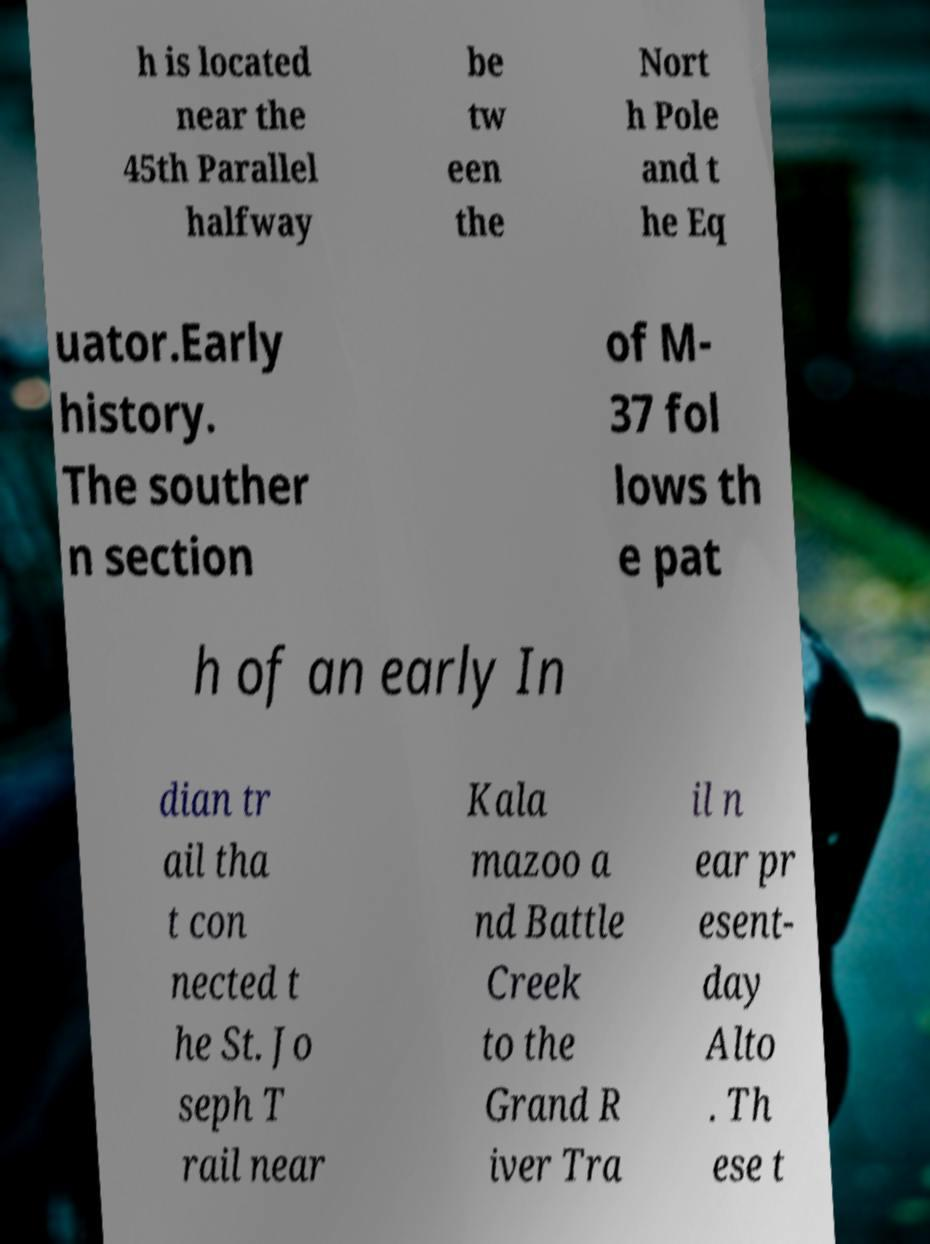Can you read and provide the text displayed in the image?This photo seems to have some interesting text. Can you extract and type it out for me? h is located near the 45th Parallel halfway be tw een the Nort h Pole and t he Eq uator.Early history. The souther n section of M- 37 fol lows th e pat h of an early In dian tr ail tha t con nected t he St. Jo seph T rail near Kala mazoo a nd Battle Creek to the Grand R iver Tra il n ear pr esent- day Alto . Th ese t 